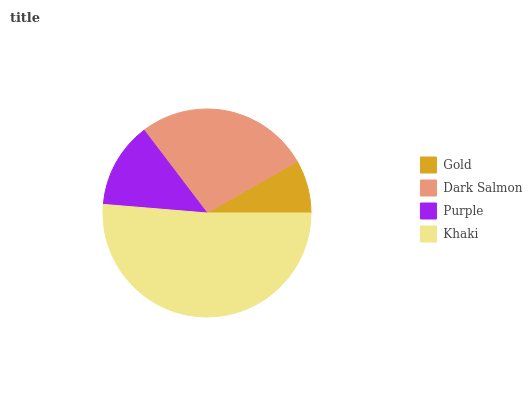Is Gold the minimum?
Answer yes or no. Yes. Is Khaki the maximum?
Answer yes or no. Yes. Is Dark Salmon the minimum?
Answer yes or no. No. Is Dark Salmon the maximum?
Answer yes or no. No. Is Dark Salmon greater than Gold?
Answer yes or no. Yes. Is Gold less than Dark Salmon?
Answer yes or no. Yes. Is Gold greater than Dark Salmon?
Answer yes or no. No. Is Dark Salmon less than Gold?
Answer yes or no. No. Is Dark Salmon the high median?
Answer yes or no. Yes. Is Purple the low median?
Answer yes or no. Yes. Is Khaki the high median?
Answer yes or no. No. Is Khaki the low median?
Answer yes or no. No. 